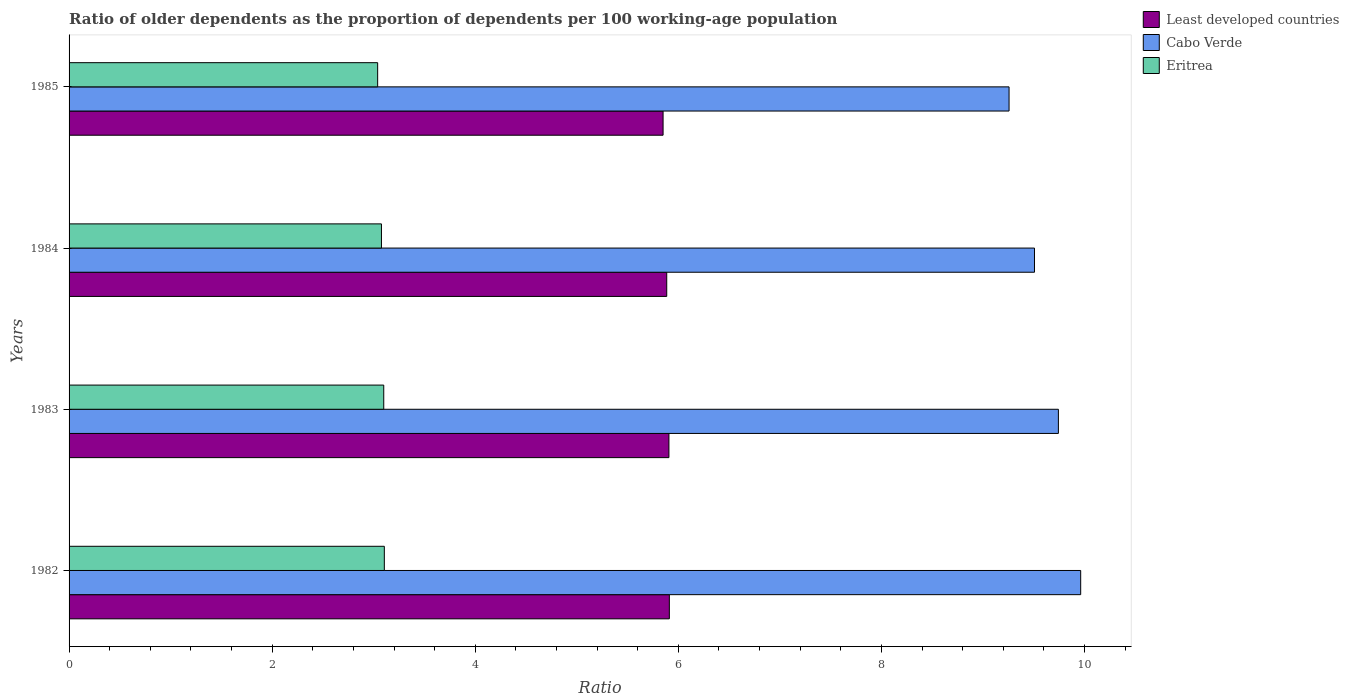How many different coloured bars are there?
Your answer should be compact. 3. Are the number of bars per tick equal to the number of legend labels?
Provide a succinct answer. Yes. How many bars are there on the 4th tick from the top?
Your answer should be very brief. 3. What is the age dependency ratio(old) in Cabo Verde in 1982?
Offer a terse response. 9.96. Across all years, what is the maximum age dependency ratio(old) in Eritrea?
Keep it short and to the point. 3.1. Across all years, what is the minimum age dependency ratio(old) in Cabo Verde?
Offer a very short reply. 9.26. What is the total age dependency ratio(old) in Eritrea in the graph?
Provide a succinct answer. 12.32. What is the difference between the age dependency ratio(old) in Eritrea in 1983 and that in 1984?
Ensure brevity in your answer.  0.02. What is the difference between the age dependency ratio(old) in Least developed countries in 1983 and the age dependency ratio(old) in Eritrea in 1984?
Offer a terse response. 2.83. What is the average age dependency ratio(old) in Cabo Verde per year?
Your answer should be compact. 9.62. In the year 1982, what is the difference between the age dependency ratio(old) in Eritrea and age dependency ratio(old) in Least developed countries?
Your response must be concise. -2.81. In how many years, is the age dependency ratio(old) in Eritrea greater than 10 ?
Provide a short and direct response. 0. What is the ratio of the age dependency ratio(old) in Cabo Verde in 1982 to that in 1985?
Make the answer very short. 1.08. What is the difference between the highest and the second highest age dependency ratio(old) in Least developed countries?
Offer a terse response. 0. What is the difference between the highest and the lowest age dependency ratio(old) in Least developed countries?
Give a very brief answer. 0.06. In how many years, is the age dependency ratio(old) in Eritrea greater than the average age dependency ratio(old) in Eritrea taken over all years?
Your answer should be compact. 2. What does the 1st bar from the top in 1984 represents?
Make the answer very short. Eritrea. What does the 2nd bar from the bottom in 1982 represents?
Make the answer very short. Cabo Verde. Is it the case that in every year, the sum of the age dependency ratio(old) in Eritrea and age dependency ratio(old) in Least developed countries is greater than the age dependency ratio(old) in Cabo Verde?
Keep it short and to the point. No. How many years are there in the graph?
Offer a very short reply. 4. Does the graph contain any zero values?
Make the answer very short. No. What is the title of the graph?
Ensure brevity in your answer.  Ratio of older dependents as the proportion of dependents per 100 working-age population. What is the label or title of the X-axis?
Your response must be concise. Ratio. What is the label or title of the Y-axis?
Provide a succinct answer. Years. What is the Ratio of Least developed countries in 1982?
Offer a terse response. 5.91. What is the Ratio in Cabo Verde in 1982?
Make the answer very short. 9.96. What is the Ratio in Eritrea in 1982?
Your answer should be compact. 3.1. What is the Ratio in Least developed countries in 1983?
Keep it short and to the point. 5.91. What is the Ratio in Cabo Verde in 1983?
Offer a terse response. 9.74. What is the Ratio of Eritrea in 1983?
Make the answer very short. 3.1. What is the Ratio in Least developed countries in 1984?
Your answer should be very brief. 5.89. What is the Ratio in Cabo Verde in 1984?
Give a very brief answer. 9.51. What is the Ratio in Eritrea in 1984?
Provide a succinct answer. 3.08. What is the Ratio of Least developed countries in 1985?
Offer a very short reply. 5.85. What is the Ratio in Cabo Verde in 1985?
Provide a short and direct response. 9.26. What is the Ratio of Eritrea in 1985?
Provide a succinct answer. 3.04. Across all years, what is the maximum Ratio of Least developed countries?
Make the answer very short. 5.91. Across all years, what is the maximum Ratio in Cabo Verde?
Your answer should be compact. 9.96. Across all years, what is the maximum Ratio in Eritrea?
Offer a very short reply. 3.1. Across all years, what is the minimum Ratio in Least developed countries?
Your answer should be very brief. 5.85. Across all years, what is the minimum Ratio of Cabo Verde?
Keep it short and to the point. 9.26. Across all years, what is the minimum Ratio of Eritrea?
Your answer should be compact. 3.04. What is the total Ratio of Least developed countries in the graph?
Make the answer very short. 23.55. What is the total Ratio of Cabo Verde in the graph?
Offer a very short reply. 38.47. What is the total Ratio in Eritrea in the graph?
Offer a terse response. 12.32. What is the difference between the Ratio of Least developed countries in 1982 and that in 1983?
Your response must be concise. 0. What is the difference between the Ratio in Cabo Verde in 1982 and that in 1983?
Keep it short and to the point. 0.22. What is the difference between the Ratio in Eritrea in 1982 and that in 1983?
Your answer should be compact. 0.01. What is the difference between the Ratio in Least developed countries in 1982 and that in 1984?
Provide a short and direct response. 0.03. What is the difference between the Ratio in Cabo Verde in 1982 and that in 1984?
Your answer should be very brief. 0.46. What is the difference between the Ratio of Eritrea in 1982 and that in 1984?
Ensure brevity in your answer.  0.03. What is the difference between the Ratio in Least developed countries in 1982 and that in 1985?
Keep it short and to the point. 0.06. What is the difference between the Ratio of Cabo Verde in 1982 and that in 1985?
Offer a terse response. 0.71. What is the difference between the Ratio of Eritrea in 1982 and that in 1985?
Offer a terse response. 0.07. What is the difference between the Ratio in Least developed countries in 1983 and that in 1984?
Your answer should be very brief. 0.02. What is the difference between the Ratio in Cabo Verde in 1983 and that in 1984?
Offer a terse response. 0.24. What is the difference between the Ratio of Eritrea in 1983 and that in 1984?
Make the answer very short. 0.02. What is the difference between the Ratio of Least developed countries in 1983 and that in 1985?
Make the answer very short. 0.06. What is the difference between the Ratio of Cabo Verde in 1983 and that in 1985?
Keep it short and to the point. 0.49. What is the difference between the Ratio of Least developed countries in 1984 and that in 1985?
Your answer should be compact. 0.04. What is the difference between the Ratio in Cabo Verde in 1984 and that in 1985?
Offer a very short reply. 0.25. What is the difference between the Ratio in Eritrea in 1984 and that in 1985?
Your answer should be compact. 0.04. What is the difference between the Ratio in Least developed countries in 1982 and the Ratio in Cabo Verde in 1983?
Provide a short and direct response. -3.83. What is the difference between the Ratio in Least developed countries in 1982 and the Ratio in Eritrea in 1983?
Ensure brevity in your answer.  2.81. What is the difference between the Ratio in Cabo Verde in 1982 and the Ratio in Eritrea in 1983?
Keep it short and to the point. 6.86. What is the difference between the Ratio in Least developed countries in 1982 and the Ratio in Cabo Verde in 1984?
Your response must be concise. -3.6. What is the difference between the Ratio in Least developed countries in 1982 and the Ratio in Eritrea in 1984?
Your response must be concise. 2.83. What is the difference between the Ratio of Cabo Verde in 1982 and the Ratio of Eritrea in 1984?
Offer a terse response. 6.89. What is the difference between the Ratio of Least developed countries in 1982 and the Ratio of Cabo Verde in 1985?
Give a very brief answer. -3.35. What is the difference between the Ratio of Least developed countries in 1982 and the Ratio of Eritrea in 1985?
Keep it short and to the point. 2.87. What is the difference between the Ratio of Cabo Verde in 1982 and the Ratio of Eritrea in 1985?
Offer a very short reply. 6.92. What is the difference between the Ratio of Least developed countries in 1983 and the Ratio of Cabo Verde in 1984?
Your response must be concise. -3.6. What is the difference between the Ratio in Least developed countries in 1983 and the Ratio in Eritrea in 1984?
Your answer should be compact. 2.83. What is the difference between the Ratio in Cabo Verde in 1983 and the Ratio in Eritrea in 1984?
Your answer should be compact. 6.67. What is the difference between the Ratio of Least developed countries in 1983 and the Ratio of Cabo Verde in 1985?
Your response must be concise. -3.35. What is the difference between the Ratio in Least developed countries in 1983 and the Ratio in Eritrea in 1985?
Your answer should be compact. 2.87. What is the difference between the Ratio in Cabo Verde in 1983 and the Ratio in Eritrea in 1985?
Your response must be concise. 6.7. What is the difference between the Ratio in Least developed countries in 1984 and the Ratio in Cabo Verde in 1985?
Give a very brief answer. -3.37. What is the difference between the Ratio of Least developed countries in 1984 and the Ratio of Eritrea in 1985?
Make the answer very short. 2.85. What is the difference between the Ratio of Cabo Verde in 1984 and the Ratio of Eritrea in 1985?
Your answer should be very brief. 6.47. What is the average Ratio of Least developed countries per year?
Provide a succinct answer. 5.89. What is the average Ratio in Cabo Verde per year?
Provide a succinct answer. 9.62. What is the average Ratio of Eritrea per year?
Your response must be concise. 3.08. In the year 1982, what is the difference between the Ratio in Least developed countries and Ratio in Cabo Verde?
Your response must be concise. -4.05. In the year 1982, what is the difference between the Ratio in Least developed countries and Ratio in Eritrea?
Offer a terse response. 2.81. In the year 1982, what is the difference between the Ratio in Cabo Verde and Ratio in Eritrea?
Your answer should be very brief. 6.86. In the year 1983, what is the difference between the Ratio of Least developed countries and Ratio of Cabo Verde?
Offer a terse response. -3.84. In the year 1983, what is the difference between the Ratio of Least developed countries and Ratio of Eritrea?
Keep it short and to the point. 2.81. In the year 1983, what is the difference between the Ratio of Cabo Verde and Ratio of Eritrea?
Provide a succinct answer. 6.64. In the year 1984, what is the difference between the Ratio of Least developed countries and Ratio of Cabo Verde?
Your answer should be very brief. -3.62. In the year 1984, what is the difference between the Ratio in Least developed countries and Ratio in Eritrea?
Make the answer very short. 2.81. In the year 1984, what is the difference between the Ratio in Cabo Verde and Ratio in Eritrea?
Your answer should be very brief. 6.43. In the year 1985, what is the difference between the Ratio in Least developed countries and Ratio in Cabo Verde?
Make the answer very short. -3.41. In the year 1985, what is the difference between the Ratio of Least developed countries and Ratio of Eritrea?
Provide a short and direct response. 2.81. In the year 1985, what is the difference between the Ratio in Cabo Verde and Ratio in Eritrea?
Keep it short and to the point. 6.22. What is the ratio of the Ratio in Least developed countries in 1982 to that in 1983?
Your answer should be compact. 1. What is the ratio of the Ratio of Cabo Verde in 1982 to that in 1983?
Ensure brevity in your answer.  1.02. What is the ratio of the Ratio in Eritrea in 1982 to that in 1983?
Provide a short and direct response. 1. What is the ratio of the Ratio in Least developed countries in 1982 to that in 1984?
Keep it short and to the point. 1. What is the ratio of the Ratio in Cabo Verde in 1982 to that in 1984?
Make the answer very short. 1.05. What is the ratio of the Ratio in Eritrea in 1982 to that in 1984?
Your response must be concise. 1.01. What is the ratio of the Ratio of Least developed countries in 1982 to that in 1985?
Keep it short and to the point. 1.01. What is the ratio of the Ratio in Cabo Verde in 1982 to that in 1985?
Your answer should be very brief. 1.08. What is the ratio of the Ratio of Eritrea in 1982 to that in 1985?
Keep it short and to the point. 1.02. What is the ratio of the Ratio of Cabo Verde in 1983 to that in 1984?
Your answer should be compact. 1.02. What is the ratio of the Ratio in Eritrea in 1983 to that in 1984?
Ensure brevity in your answer.  1.01. What is the ratio of the Ratio in Least developed countries in 1983 to that in 1985?
Your response must be concise. 1.01. What is the ratio of the Ratio of Cabo Verde in 1983 to that in 1985?
Ensure brevity in your answer.  1.05. What is the ratio of the Ratio in Eritrea in 1983 to that in 1985?
Your response must be concise. 1.02. What is the ratio of the Ratio of Eritrea in 1984 to that in 1985?
Give a very brief answer. 1.01. What is the difference between the highest and the second highest Ratio in Least developed countries?
Provide a short and direct response. 0. What is the difference between the highest and the second highest Ratio in Cabo Verde?
Your answer should be very brief. 0.22. What is the difference between the highest and the second highest Ratio in Eritrea?
Give a very brief answer. 0.01. What is the difference between the highest and the lowest Ratio of Least developed countries?
Ensure brevity in your answer.  0.06. What is the difference between the highest and the lowest Ratio of Cabo Verde?
Make the answer very short. 0.71. What is the difference between the highest and the lowest Ratio in Eritrea?
Offer a terse response. 0.07. 